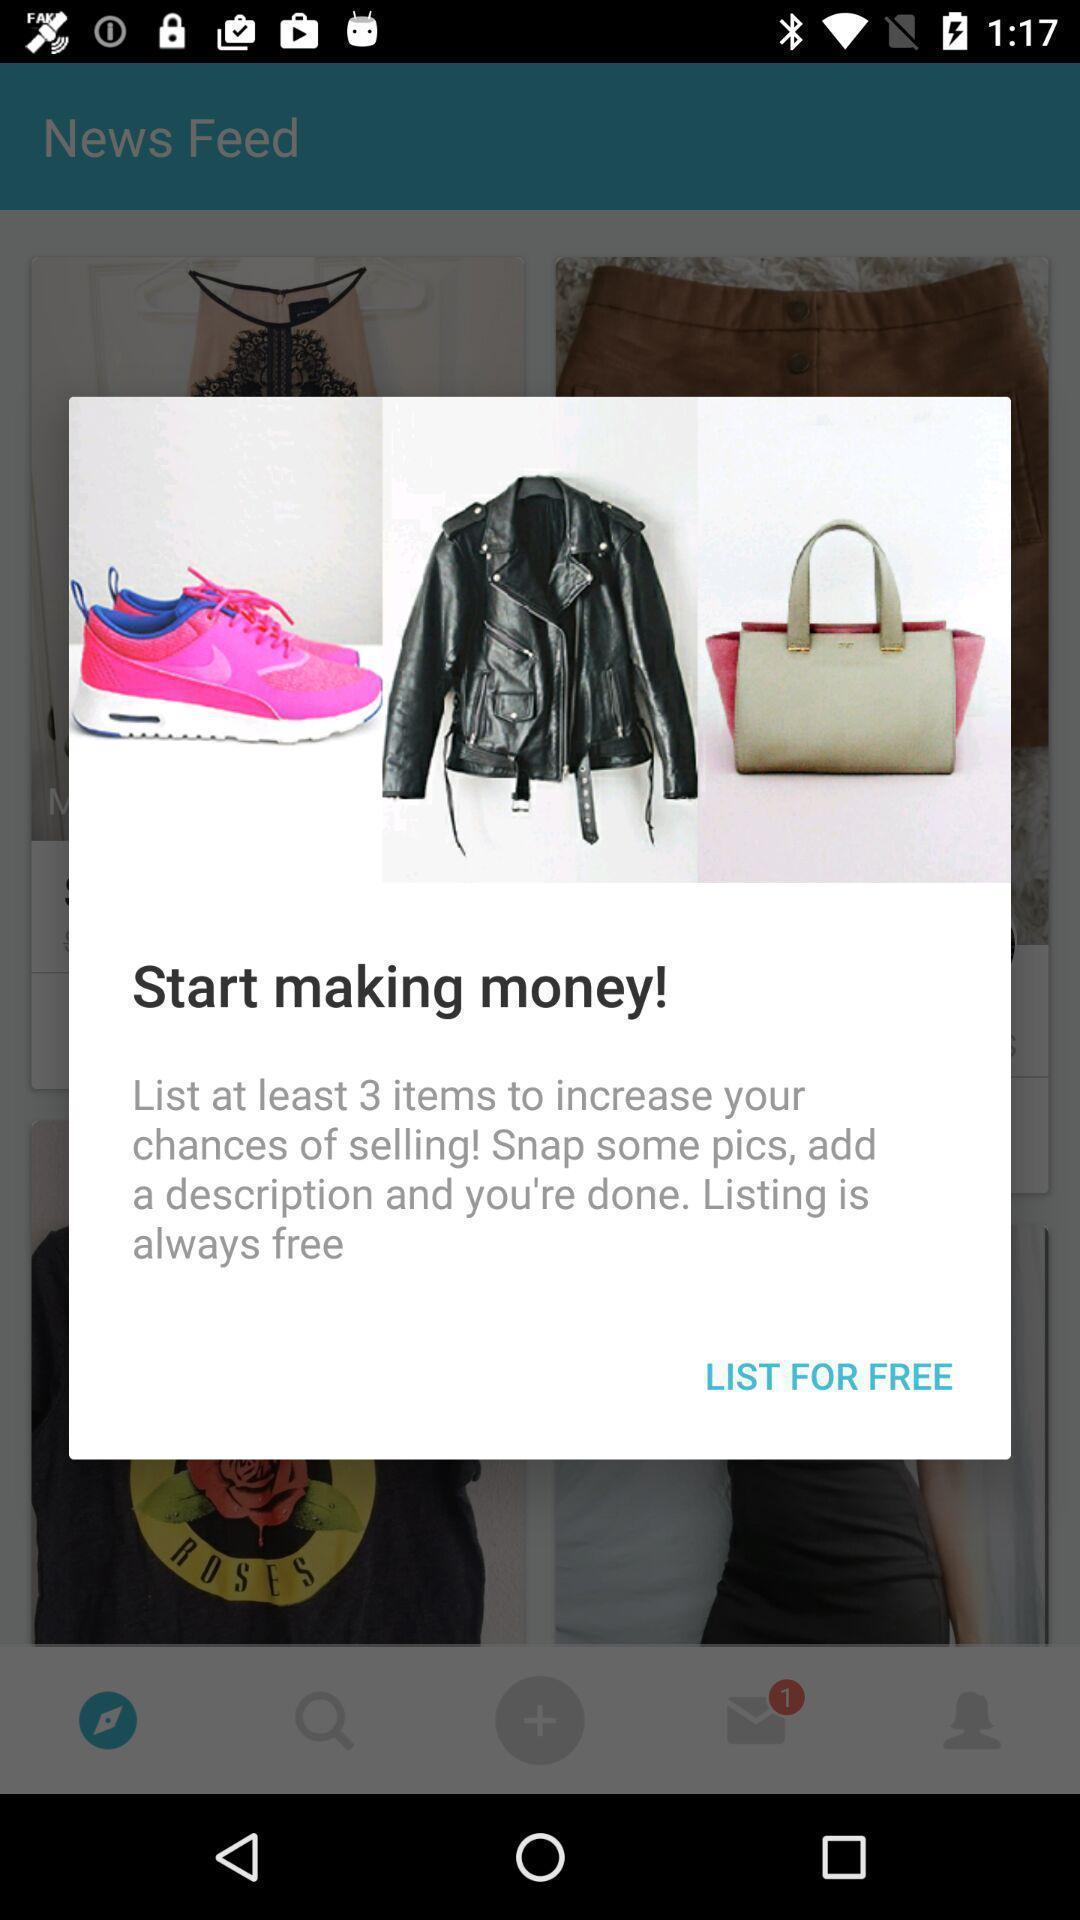What is the overall content of this screenshot? Pop-up displaying the products notification. 